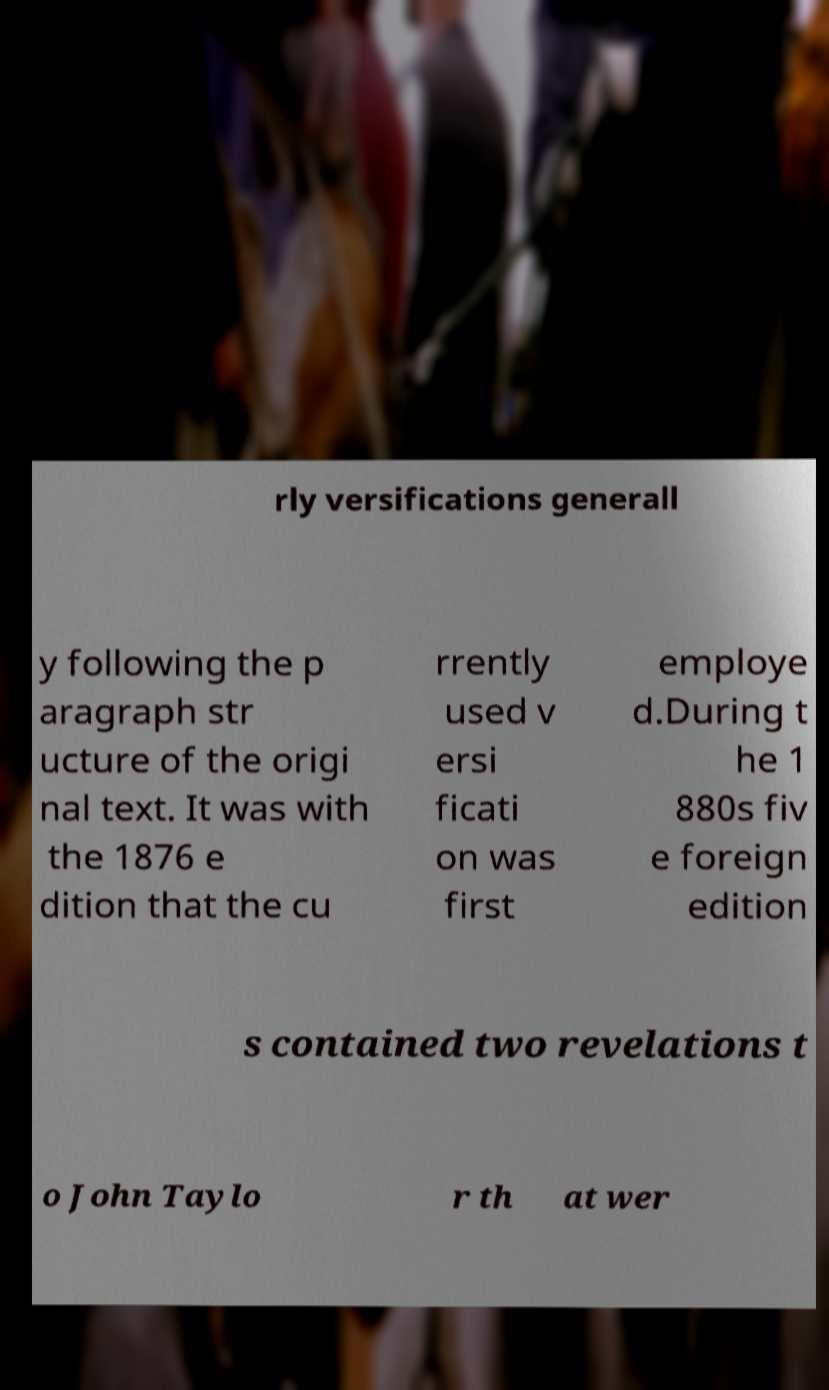Can you accurately transcribe the text from the provided image for me? rly versifications generall y following the p aragraph str ucture of the origi nal text. It was with the 1876 e dition that the cu rrently used v ersi ficati on was first employe d.During t he 1 880s fiv e foreign edition s contained two revelations t o John Taylo r th at wer 